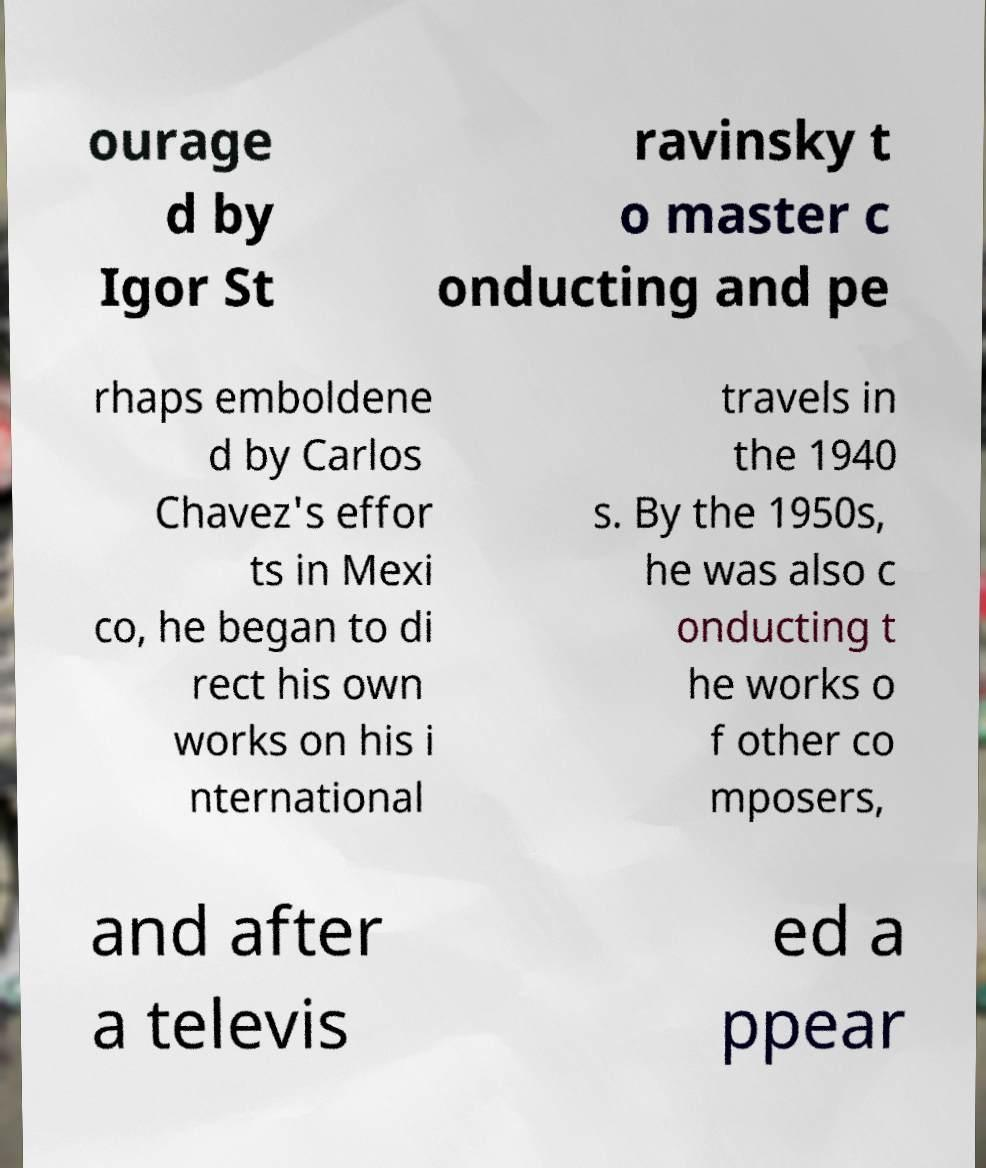For documentation purposes, I need the text within this image transcribed. Could you provide that? ourage d by Igor St ravinsky t o master c onducting and pe rhaps emboldene d by Carlos Chavez's effor ts in Mexi co, he began to di rect his own works on his i nternational travels in the 1940 s. By the 1950s, he was also c onducting t he works o f other co mposers, and after a televis ed a ppear 